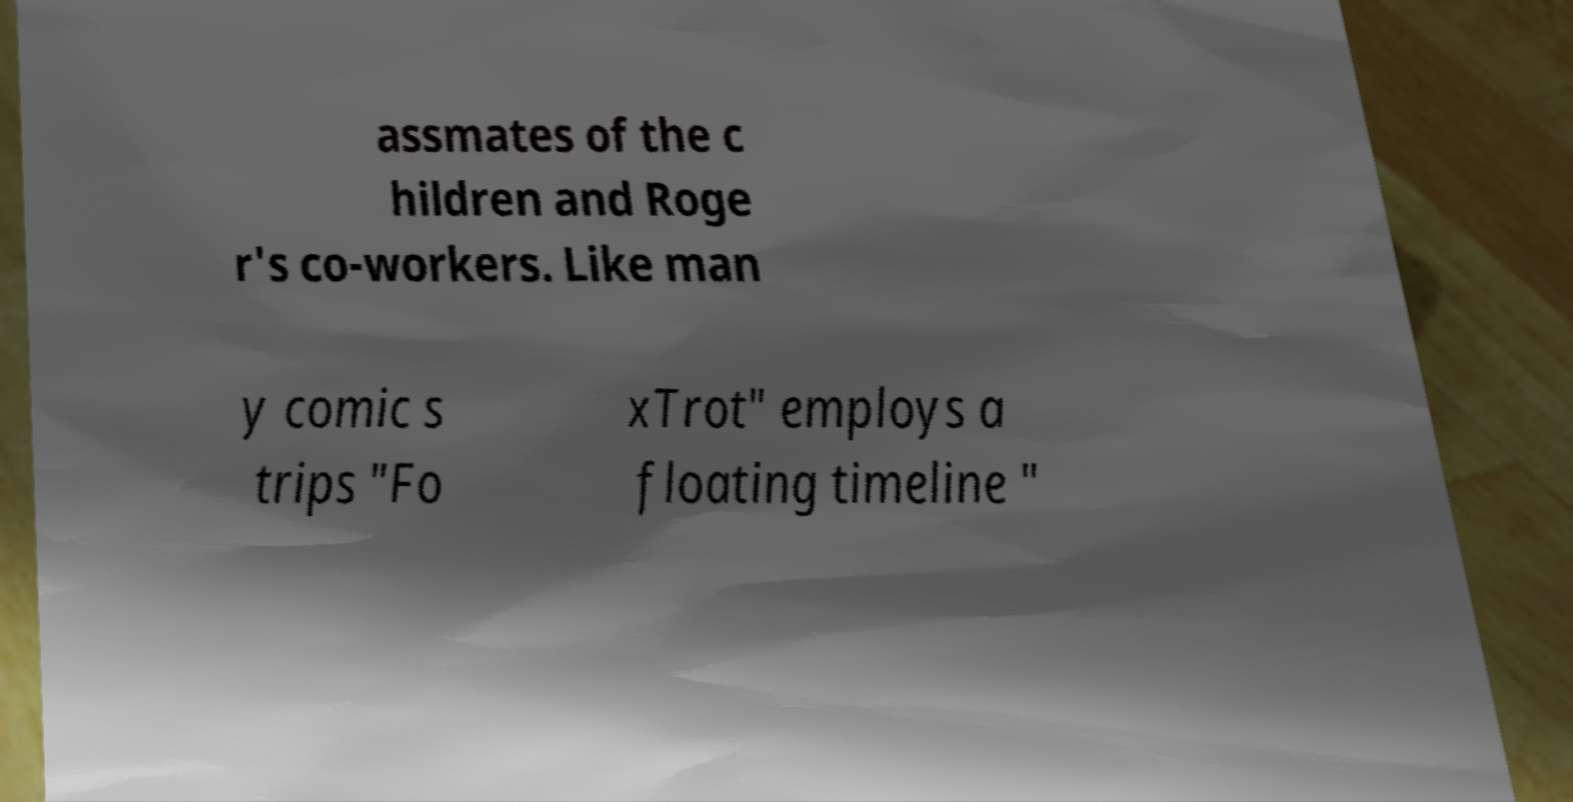Could you extract and type out the text from this image? assmates of the c hildren and Roge r's co-workers. Like man y comic s trips "Fo xTrot" employs a floating timeline " 